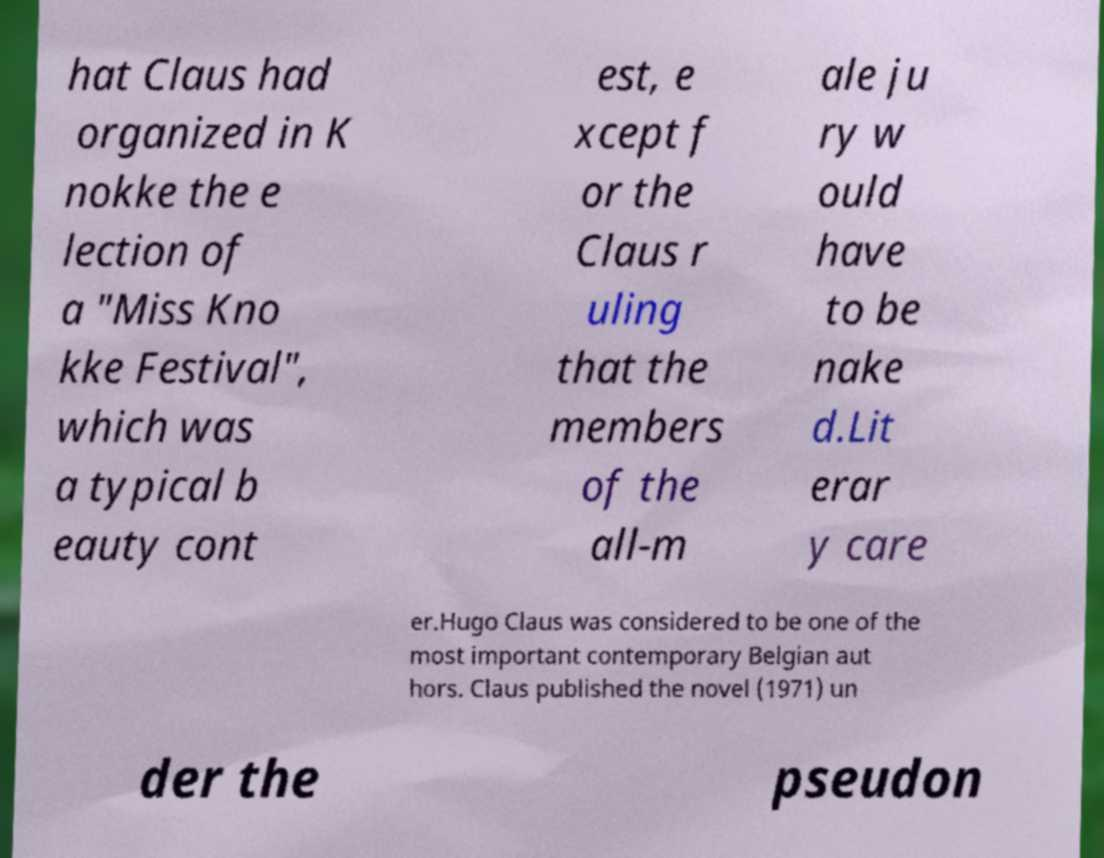Could you assist in decoding the text presented in this image and type it out clearly? hat Claus had organized in K nokke the e lection of a "Miss Kno kke Festival", which was a typical b eauty cont est, e xcept f or the Claus r uling that the members of the all-m ale ju ry w ould have to be nake d.Lit erar y care er.Hugo Claus was considered to be one of the most important contemporary Belgian aut hors. Claus published the novel (1971) un der the pseudon 